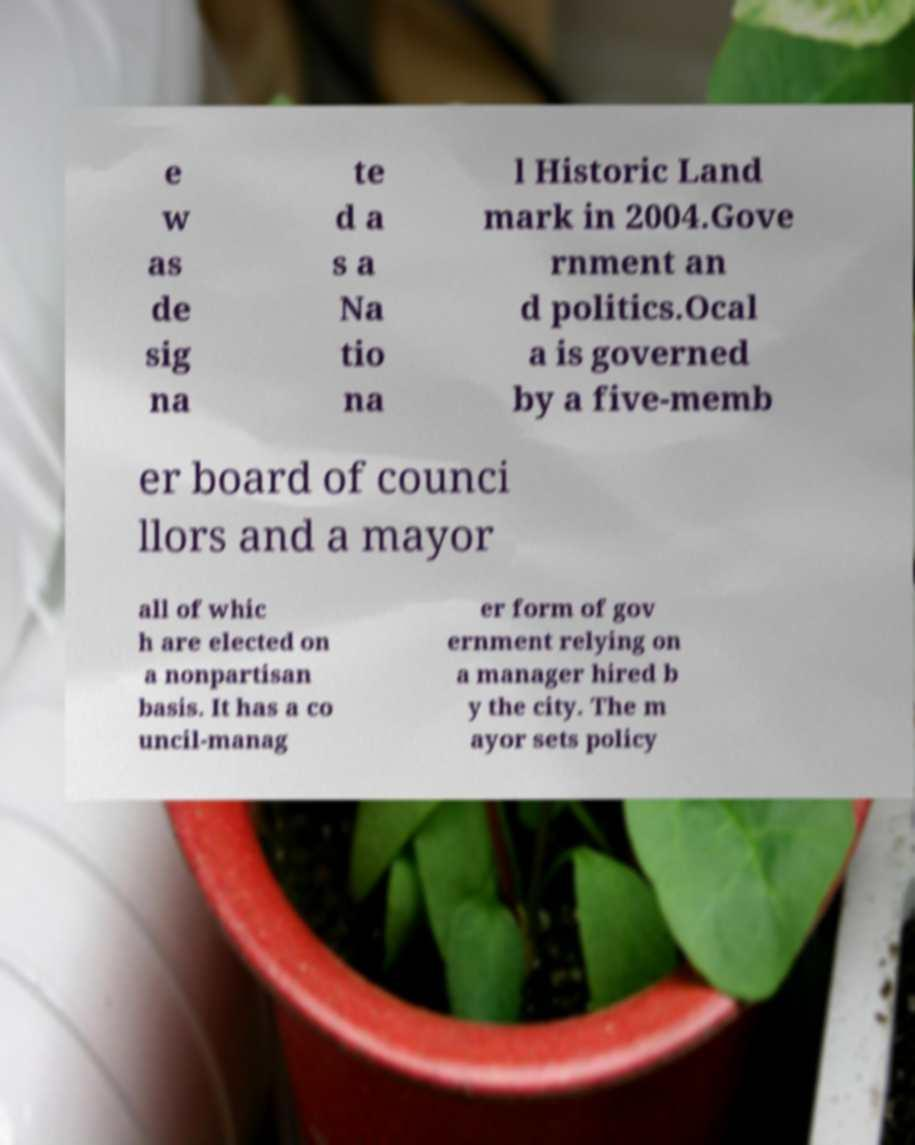Could you extract and type out the text from this image? e w as de sig na te d a s a Na tio na l Historic Land mark in 2004.Gove rnment an d politics.Ocal a is governed by a five-memb er board of counci llors and a mayor all of whic h are elected on a nonpartisan basis. It has a co uncil-manag er form of gov ernment relying on a manager hired b y the city. The m ayor sets policy 